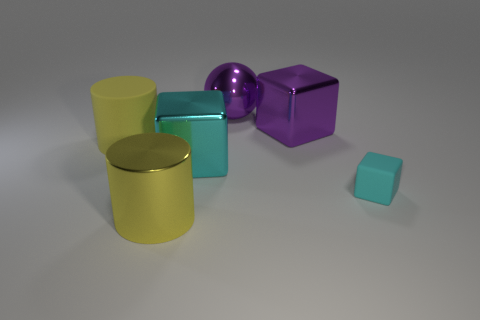Is there a big cube that has the same color as the tiny rubber thing? Yes, there is a large, purple cube that shares its color with the small, rubber-like object present in the scene. 